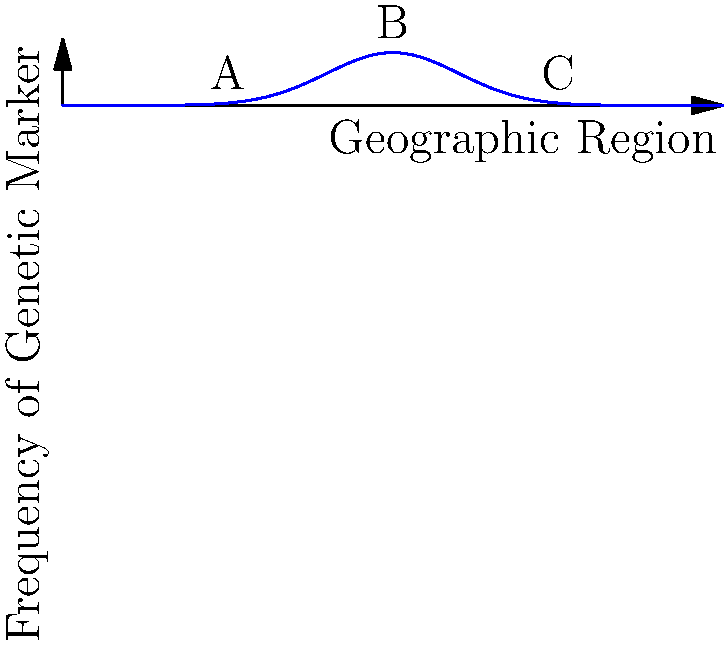The graph shows the spatial distribution of a genetic marker across different geographic regions. Which region (A, B, or C) represents the highest frequency of the genetic marker, and what type of distribution does this pattern suggest? To answer this question, we need to analyze the graph and understand the principles of genetic marker distribution:

1. The x-axis represents different geographic regions, while the y-axis shows the frequency of the genetic marker.

2. The curve represents how the frequency of the genetic marker changes across the geographic regions.

3. Observe the three labeled points:
   - A is at x ≈ 2.5
   - B is at x = 5 (the center of the distribution)
   - C is at x ≈ 7.5

4. The highest point on the curve corresponds to the highest frequency of the genetic marker. This occurs at point B.

5. The shape of the curve resembles a bell curve or Gaussian distribution. This is characteristic of many natural phenomena, including genetic marker distributions.

6. In population genetics, this type of distribution often indicates:
   - A central point of origin for the genetic marker (at B)
   - Gradual spread to neighboring regions (towards A and C)
   - Reduced frequency as distance from the origin increases

This pattern is consistent with the concept of isolation by distance in population genetics, where genetic similarity decreases with geographic distance.
Answer: B; Gaussian distribution 